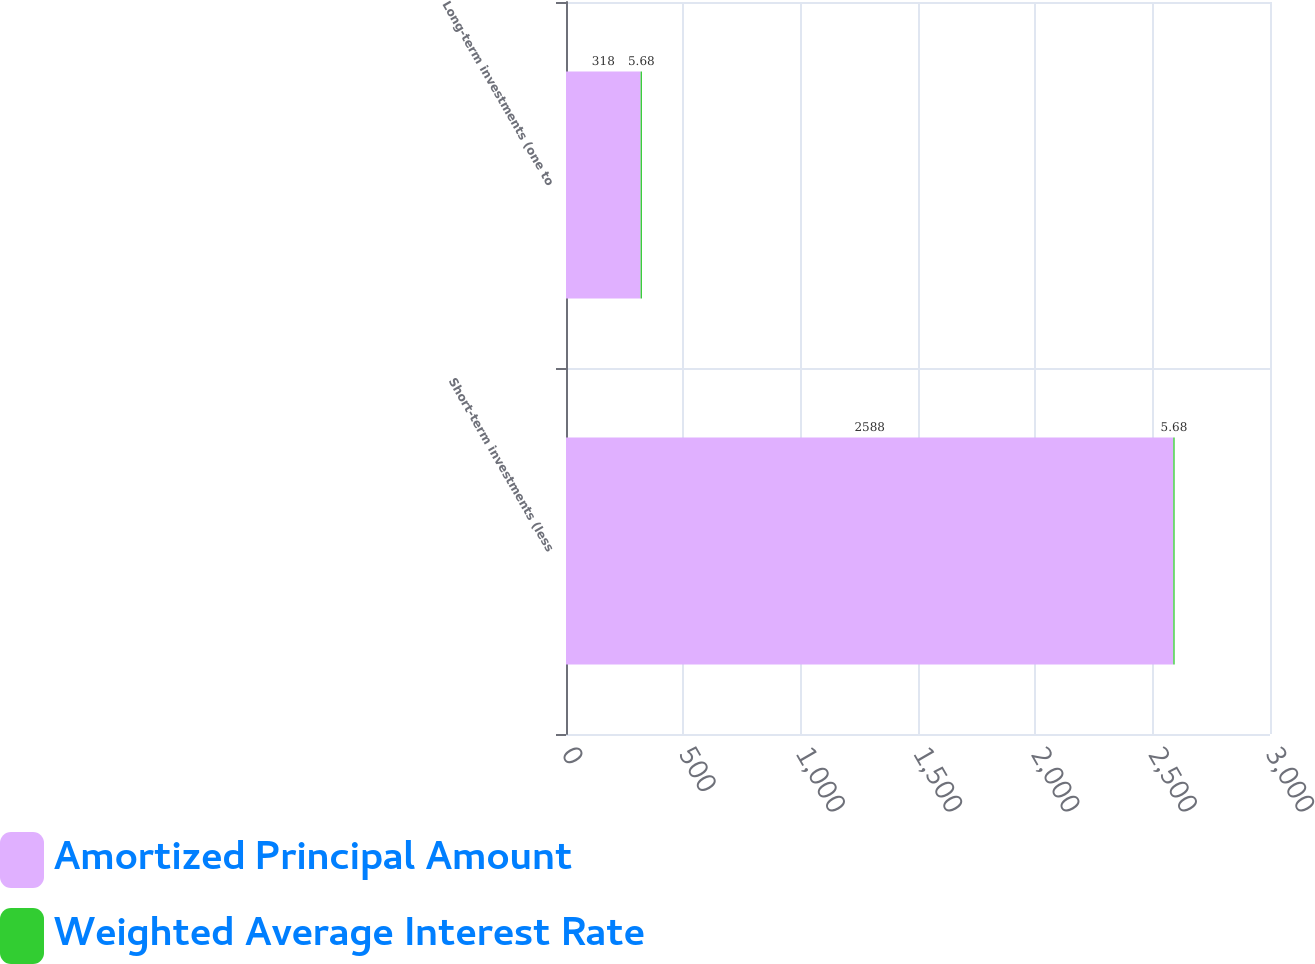Convert chart. <chart><loc_0><loc_0><loc_500><loc_500><stacked_bar_chart><ecel><fcel>Short-term investments (less<fcel>Long-term investments (one to<nl><fcel>Amortized Principal Amount<fcel>2588<fcel>318<nl><fcel>Weighted Average Interest Rate<fcel>5.68<fcel>5.68<nl></chart> 